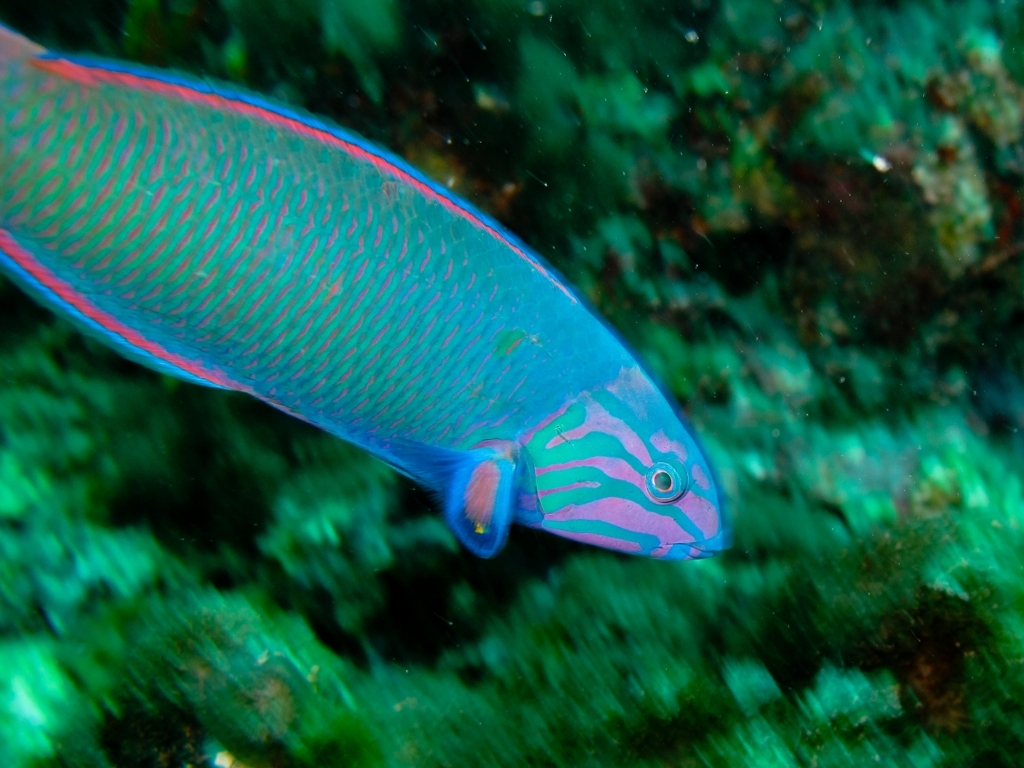What are some interesting behavioral traits of the fish in this image? Parrotfish exhibit fascinating behaviors such as the secretion of a mucus cocoon while sleeping, which may protect against parasites and predators. They are also known for their ability to change sex during their lifetime, starting as females and potentially becoming supermale parrotfish boasting even brighter colors. How does the parrotfish contribute to the sand on beaches? The parrotfish uses its beak-like teeth to scrape and eat algae from coral. The coral's limestone, which is hard to digest, gets ground up and excreted by the parrotfish, leading to fine white sand. A single parrotfish can produce hundreds of pounds of sand each year. 